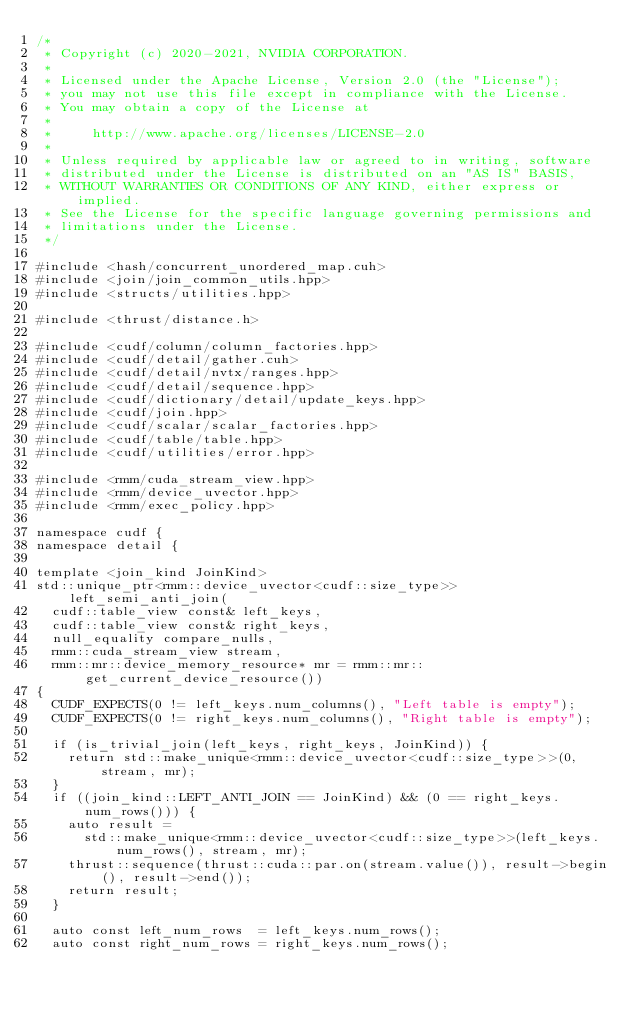<code> <loc_0><loc_0><loc_500><loc_500><_Cuda_>/*
 * Copyright (c) 2020-2021, NVIDIA CORPORATION.
 *
 * Licensed under the Apache License, Version 2.0 (the "License");
 * you may not use this file except in compliance with the License.
 * You may obtain a copy of the License at
 *
 *     http://www.apache.org/licenses/LICENSE-2.0
 *
 * Unless required by applicable law or agreed to in writing, software
 * distributed under the License is distributed on an "AS IS" BASIS,
 * WITHOUT WARRANTIES OR CONDITIONS OF ANY KIND, either express or implied.
 * See the License for the specific language governing permissions and
 * limitations under the License.
 */

#include <hash/concurrent_unordered_map.cuh>
#include <join/join_common_utils.hpp>
#include <structs/utilities.hpp>

#include <thrust/distance.h>

#include <cudf/column/column_factories.hpp>
#include <cudf/detail/gather.cuh>
#include <cudf/detail/nvtx/ranges.hpp>
#include <cudf/detail/sequence.hpp>
#include <cudf/dictionary/detail/update_keys.hpp>
#include <cudf/join.hpp>
#include <cudf/scalar/scalar_factories.hpp>
#include <cudf/table/table.hpp>
#include <cudf/utilities/error.hpp>

#include <rmm/cuda_stream_view.hpp>
#include <rmm/device_uvector.hpp>
#include <rmm/exec_policy.hpp>

namespace cudf {
namespace detail {

template <join_kind JoinKind>
std::unique_ptr<rmm::device_uvector<cudf::size_type>> left_semi_anti_join(
  cudf::table_view const& left_keys,
  cudf::table_view const& right_keys,
  null_equality compare_nulls,
  rmm::cuda_stream_view stream,
  rmm::mr::device_memory_resource* mr = rmm::mr::get_current_device_resource())
{
  CUDF_EXPECTS(0 != left_keys.num_columns(), "Left table is empty");
  CUDF_EXPECTS(0 != right_keys.num_columns(), "Right table is empty");

  if (is_trivial_join(left_keys, right_keys, JoinKind)) {
    return std::make_unique<rmm::device_uvector<cudf::size_type>>(0, stream, mr);
  }
  if ((join_kind::LEFT_ANTI_JOIN == JoinKind) && (0 == right_keys.num_rows())) {
    auto result =
      std::make_unique<rmm::device_uvector<cudf::size_type>>(left_keys.num_rows(), stream, mr);
    thrust::sequence(thrust::cuda::par.on(stream.value()), result->begin(), result->end());
    return result;
  }

  auto const left_num_rows  = left_keys.num_rows();
  auto const right_num_rows = right_keys.num_rows();
</code> 